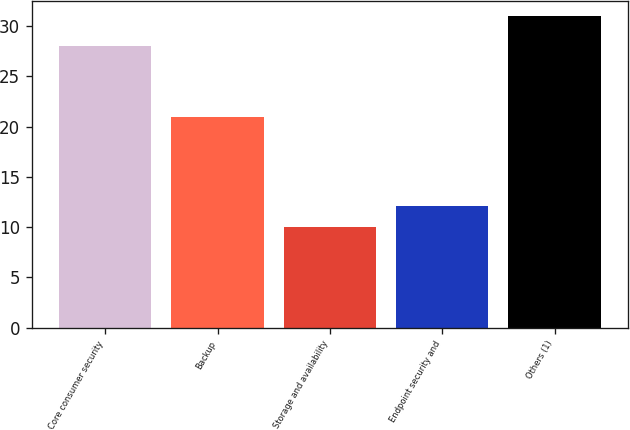<chart> <loc_0><loc_0><loc_500><loc_500><bar_chart><fcel>Core consumer security<fcel>Backup<fcel>Storage and availability<fcel>Endpoint security and<fcel>Others (1)<nl><fcel>28<fcel>21<fcel>10<fcel>12.1<fcel>31<nl></chart> 